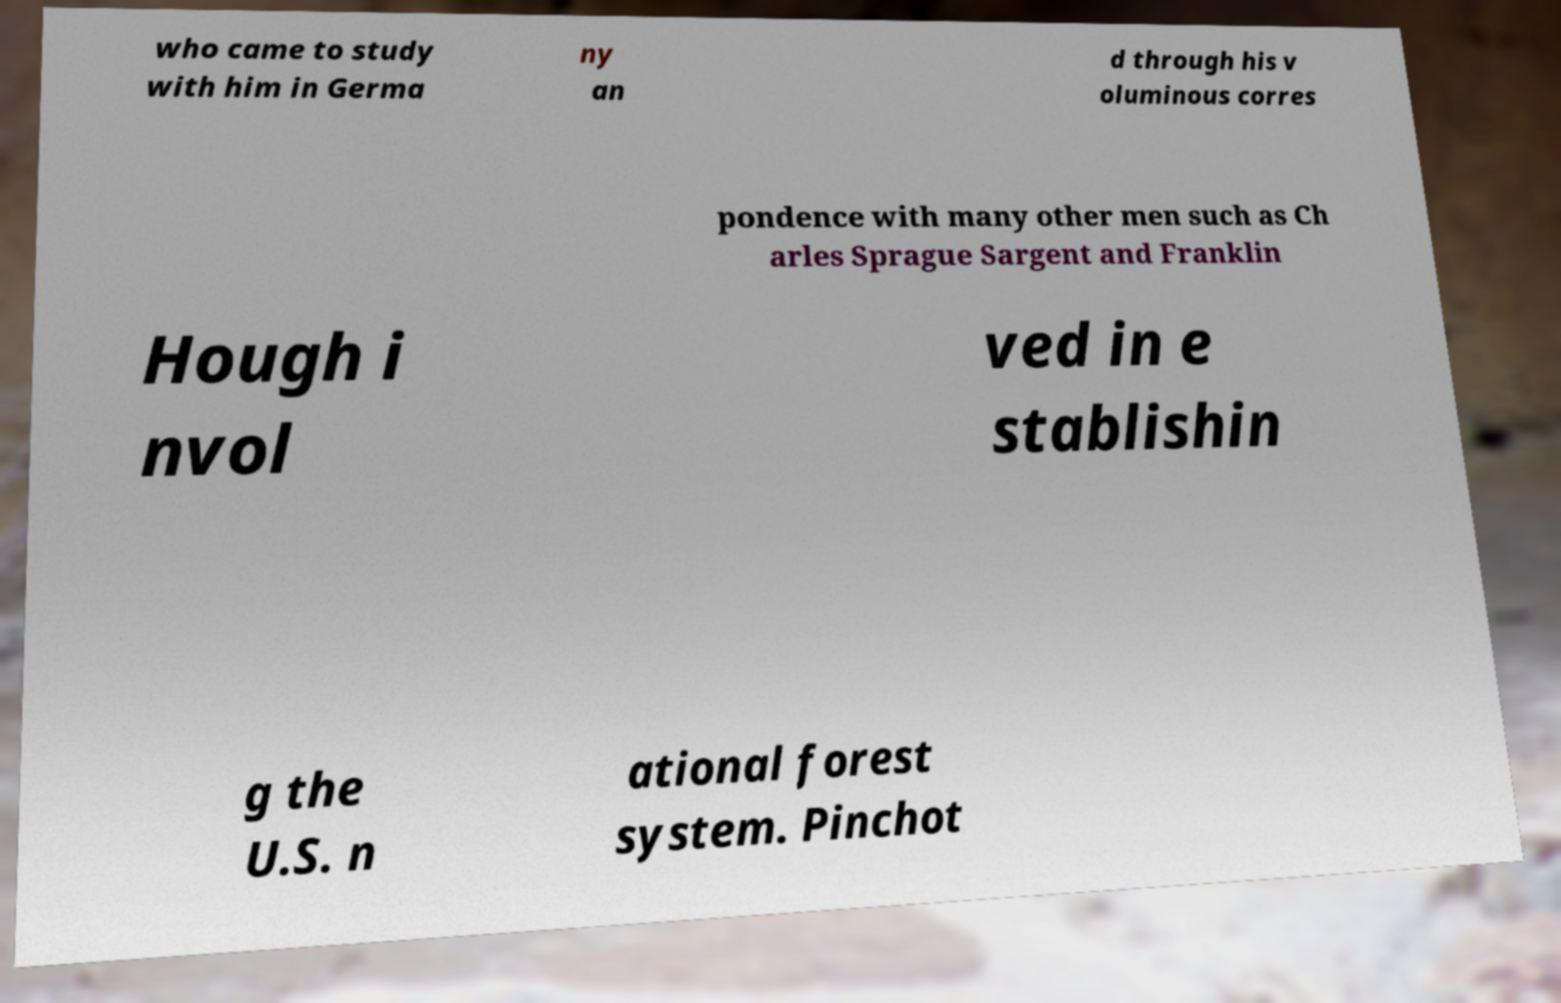Please identify and transcribe the text found in this image. who came to study with him in Germa ny an d through his v oluminous corres pondence with many other men such as Ch arles Sprague Sargent and Franklin Hough i nvol ved in e stablishin g the U.S. n ational forest system. Pinchot 